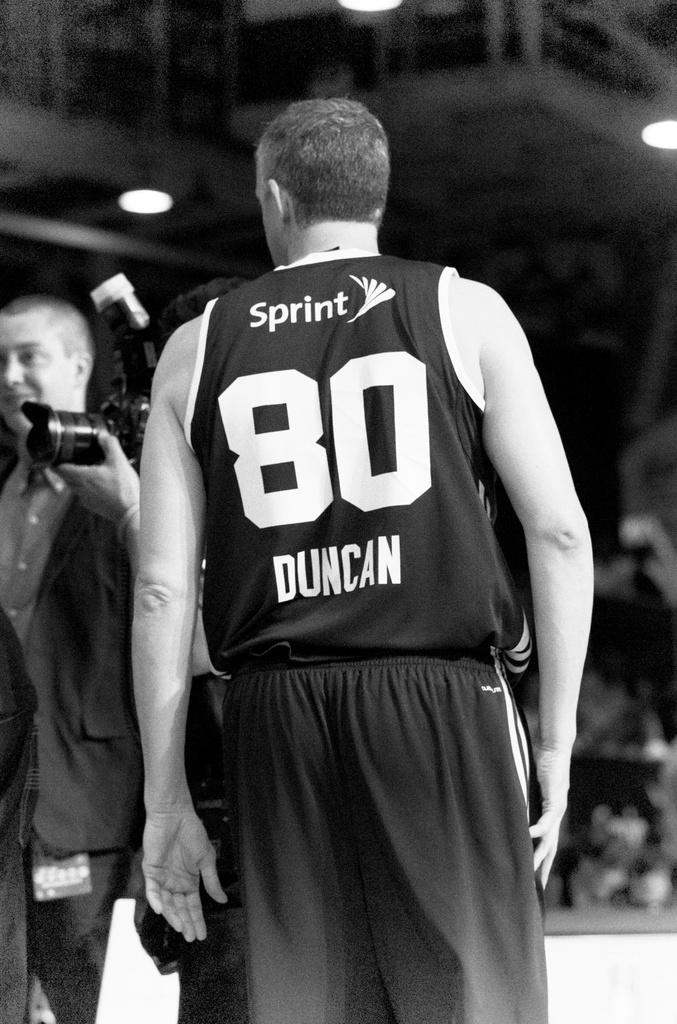<image>
Present a compact description of the photo's key features. A basketball player is wearing a uniform with Sprint printed on it. 